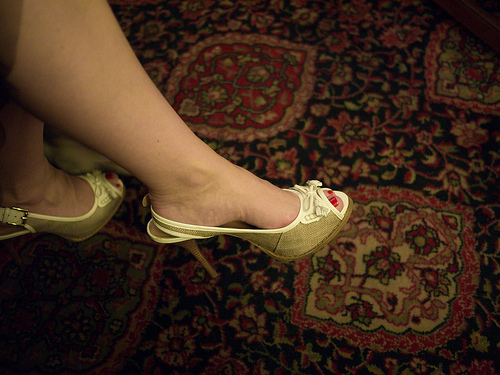<image>
Can you confirm if the shoe is next to the ground? No. The shoe is not positioned next to the ground. They are located in different areas of the scene. 